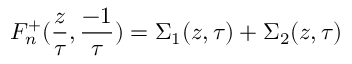<formula> <loc_0><loc_0><loc_500><loc_500>F _ { n } ^ { + } ( { \frac { z } { \tau } } , { \frac { - 1 } { \tau } } ) = \Sigma _ { 1 } ( z , \tau ) + \Sigma _ { 2 } ( z , \tau )</formula> 